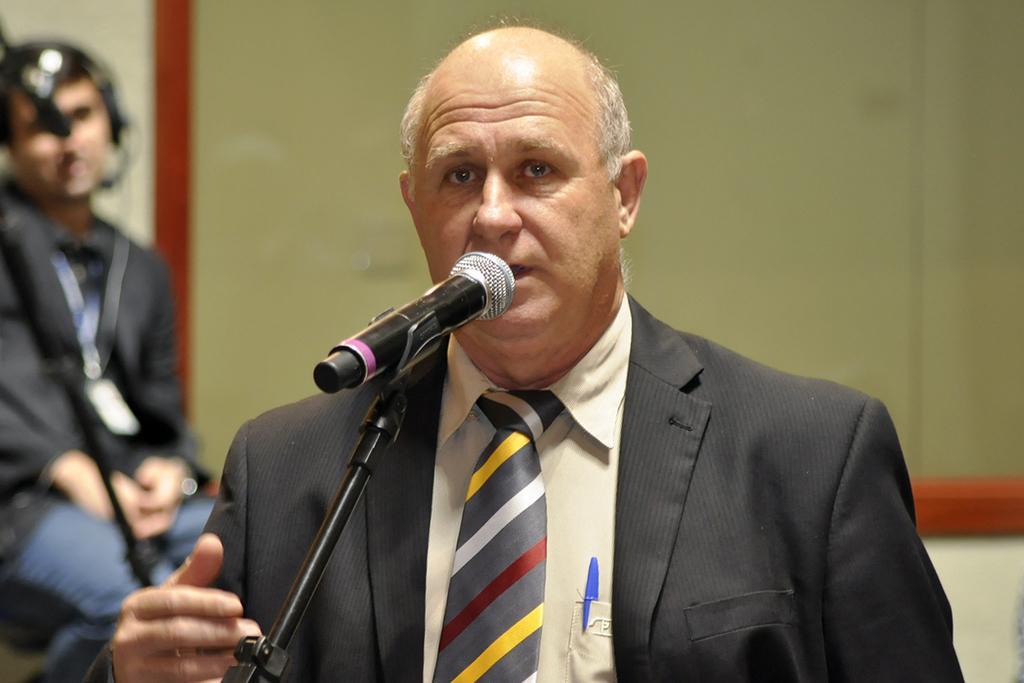How would you summarize this image in a sentence or two? In this image, we can see an old man in a suit is talking in-front of a microphone. Here there is a stand. Background there is a blur view. Here we can see a board and wall. On the left side of the image, we can see a person is sitting. 